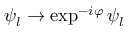<formula> <loc_0><loc_0><loc_500><loc_500>\psi _ { l } \to \exp ^ { - i \varphi } \psi _ { l }</formula> 